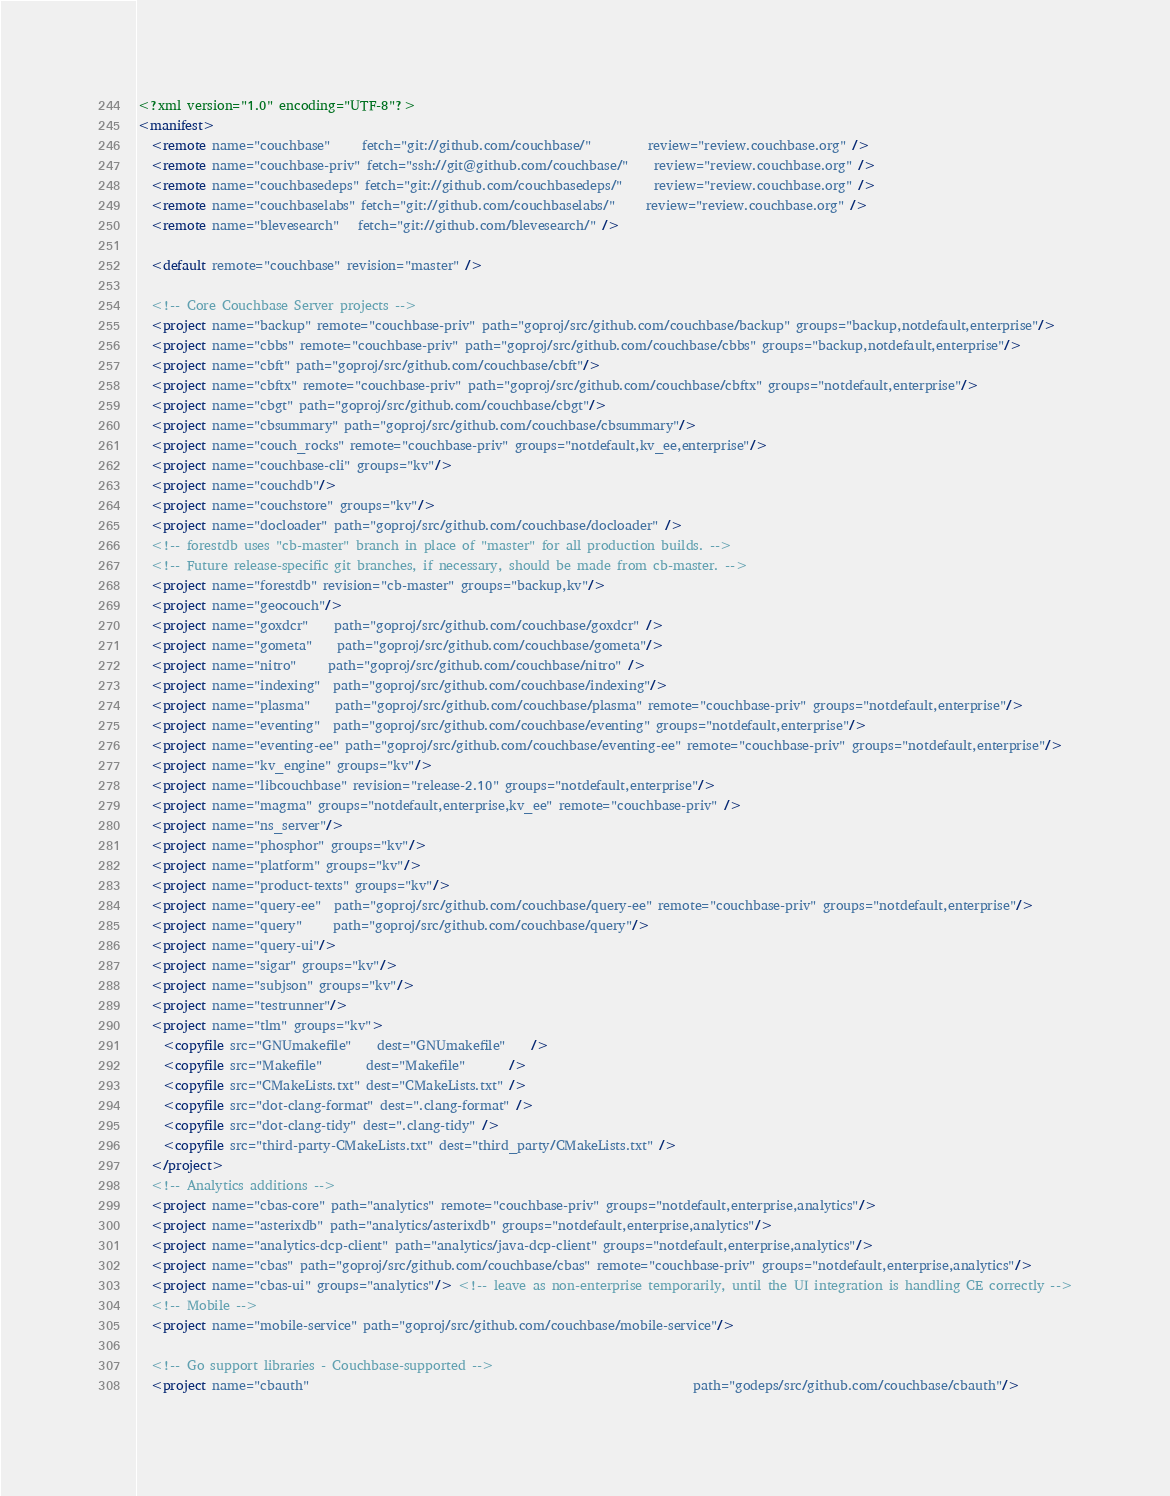<code> <loc_0><loc_0><loc_500><loc_500><_XML_><?xml version="1.0" encoding="UTF-8"?>
<manifest>
  <remote name="couchbase"     fetch="git://github.com/couchbase/"         review="review.couchbase.org" />
  <remote name="couchbase-priv" fetch="ssh://git@github.com/couchbase/"    review="review.couchbase.org" />
  <remote name="couchbasedeps" fetch="git://github.com/couchbasedeps/"     review="review.couchbase.org" />
  <remote name="couchbaselabs" fetch="git://github.com/couchbaselabs/"     review="review.couchbase.org" />
  <remote name="blevesearch"   fetch="git://github.com/blevesearch/" />

  <default remote="couchbase" revision="master" />

  <!-- Core Couchbase Server projects -->
  <project name="backup" remote="couchbase-priv" path="goproj/src/github.com/couchbase/backup" groups="backup,notdefault,enterprise"/>
  <project name="cbbs" remote="couchbase-priv" path="goproj/src/github.com/couchbase/cbbs" groups="backup,notdefault,enterprise"/>
  <project name="cbft" path="goproj/src/github.com/couchbase/cbft"/>
  <project name="cbftx" remote="couchbase-priv" path="goproj/src/github.com/couchbase/cbftx" groups="notdefault,enterprise"/>
  <project name="cbgt" path="goproj/src/github.com/couchbase/cbgt"/>
  <project name="cbsummary" path="goproj/src/github.com/couchbase/cbsummary"/>
  <project name="couch_rocks" remote="couchbase-priv" groups="notdefault,kv_ee,enterprise"/>
  <project name="couchbase-cli" groups="kv"/>
  <project name="couchdb"/>
  <project name="couchstore" groups="kv"/>
  <project name="docloader" path="goproj/src/github.com/couchbase/docloader" />
  <!-- forestdb uses "cb-master" branch in place of "master" for all production builds. -->
  <!-- Future release-specific git branches, if necessary, should be made from cb-master. -->
  <project name="forestdb" revision="cb-master" groups="backup,kv"/>
  <project name="geocouch"/>
  <project name="goxdcr"    path="goproj/src/github.com/couchbase/goxdcr" />
  <project name="gometa"    path="goproj/src/github.com/couchbase/gometa"/>
  <project name="nitro"     path="goproj/src/github.com/couchbase/nitro" />
  <project name="indexing"  path="goproj/src/github.com/couchbase/indexing"/>
  <project name="plasma"    path="goproj/src/github.com/couchbase/plasma" remote="couchbase-priv" groups="notdefault,enterprise"/>
  <project name="eventing"  path="goproj/src/github.com/couchbase/eventing" groups="notdefault,enterprise"/>
  <project name="eventing-ee" path="goproj/src/github.com/couchbase/eventing-ee" remote="couchbase-priv" groups="notdefault,enterprise"/>
  <project name="kv_engine" groups="kv"/>
  <project name="libcouchbase" revision="release-2.10" groups="notdefault,enterprise"/>
  <project name="magma" groups="notdefault,enterprise,kv_ee" remote="couchbase-priv" />
  <project name="ns_server"/>
  <project name="phosphor" groups="kv"/>
  <project name="platform" groups="kv"/>
  <project name="product-texts" groups="kv"/>
  <project name="query-ee"  path="goproj/src/github.com/couchbase/query-ee" remote="couchbase-priv" groups="notdefault,enterprise"/>
  <project name="query"     path="goproj/src/github.com/couchbase/query"/>
  <project name="query-ui"/>
  <project name="sigar" groups="kv"/>
  <project name="subjson" groups="kv"/>
  <project name="testrunner"/>
  <project name="tlm" groups="kv">
    <copyfile src="GNUmakefile"    dest="GNUmakefile"    />
    <copyfile src="Makefile"       dest="Makefile"       />
    <copyfile src="CMakeLists.txt" dest="CMakeLists.txt" />
    <copyfile src="dot-clang-format" dest=".clang-format" />
    <copyfile src="dot-clang-tidy" dest=".clang-tidy" />
    <copyfile src="third-party-CMakeLists.txt" dest="third_party/CMakeLists.txt" />
  </project>
  <!-- Analytics additions -->
  <project name="cbas-core" path="analytics" remote="couchbase-priv" groups="notdefault,enterprise,analytics"/>
  <project name="asterixdb" path="analytics/asterixdb" groups="notdefault,enterprise,analytics"/>
  <project name="analytics-dcp-client" path="analytics/java-dcp-client" groups="notdefault,enterprise,analytics"/>
  <project name="cbas" path="goproj/src/github.com/couchbase/cbas" remote="couchbase-priv" groups="notdefault,enterprise,analytics"/>
  <project name="cbas-ui" groups="analytics"/> <!-- leave as non-enterprise temporarily, until the UI integration is handling CE correctly -->
  <!-- Mobile -->
  <project name="mobile-service" path="goproj/src/github.com/couchbase/mobile-service"/>

  <!-- Go support libraries - Couchbase-supported -->
  <project name="cbauth"                                                             path="godeps/src/github.com/couchbase/cbauth"/></code> 